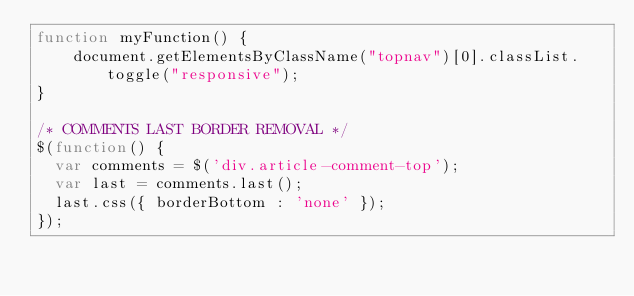Convert code to text. <code><loc_0><loc_0><loc_500><loc_500><_JavaScript_>function myFunction() {
    document.getElementsByClassName("topnav")[0].classList.toggle("responsive");
}

/* COMMENTS LAST BORDER REMOVAL */
$(function() {
  var comments = $('div.article-comment-top');
  var last = comments.last();
  last.css({ borderBottom : 'none' });
});
</code> 